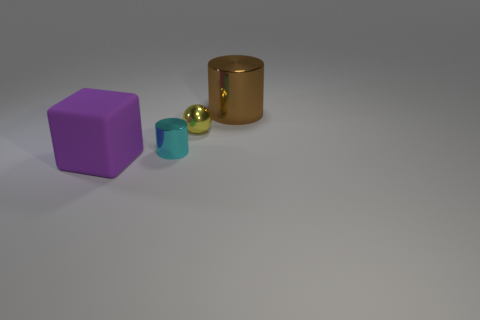Add 2 green rubber things. How many objects exist? 6 Subtract all balls. How many objects are left? 3 Subtract 0 green spheres. How many objects are left? 4 Subtract all cyan metallic things. Subtract all yellow things. How many objects are left? 2 Add 4 large metal cylinders. How many large metal cylinders are left? 5 Add 1 big blue spheres. How many big blue spheres exist? 1 